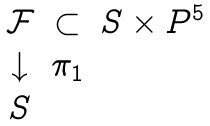Convert formula to latex. <formula><loc_0><loc_0><loc_500><loc_500>\begin{array} { c c c } \mathcal { F } & \subset & S \times P ^ { 5 } \\ \downarrow & \pi _ { 1 } & \\ S & & \end{array}</formula> 